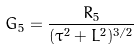<formula> <loc_0><loc_0><loc_500><loc_500>G _ { 5 } = \frac { R _ { 5 } } { ( \tau ^ { 2 } + L ^ { 2 } ) ^ { 3 / 2 } }</formula> 